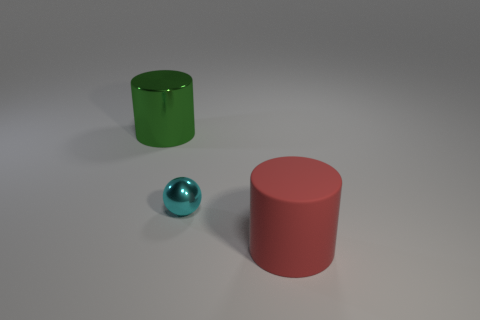Add 2 small red rubber spheres. How many objects exist? 5 Subtract all spheres. How many objects are left? 2 Subtract 0 yellow cubes. How many objects are left? 3 Subtract all large green metal things. Subtract all large shiny things. How many objects are left? 1 Add 2 big red things. How many big red things are left? 3 Add 2 metal things. How many metal things exist? 4 